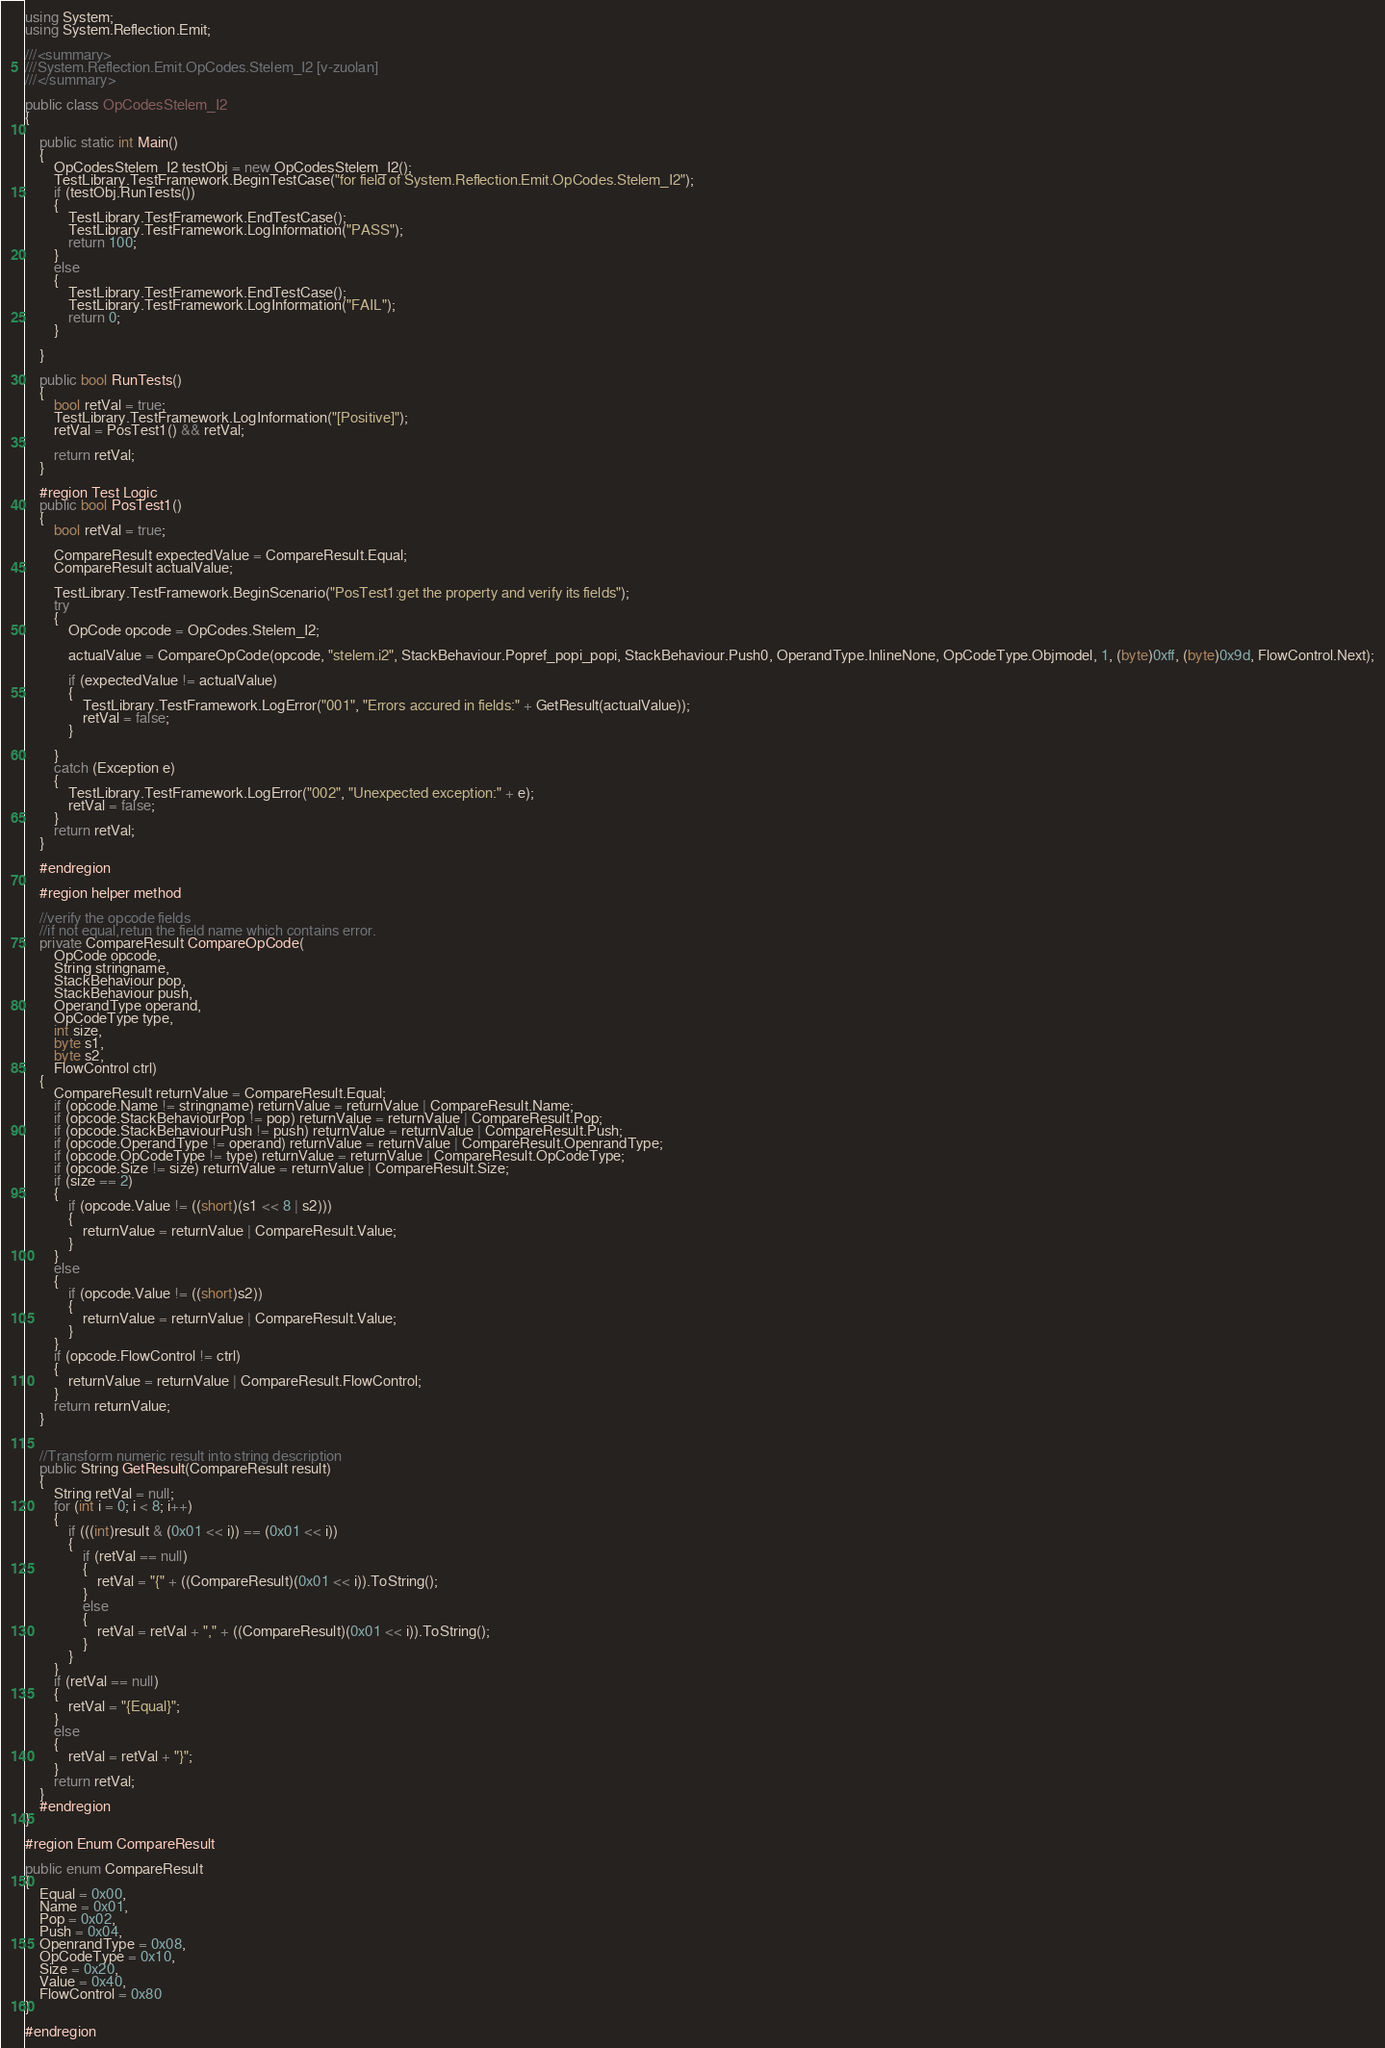Convert code to text. <code><loc_0><loc_0><loc_500><loc_500><_C#_>using System;
using System.Reflection.Emit;

///<summary>
///System.Reflection.Emit.OpCodes.Stelem_I2 [v-zuolan]
///</summary>

public class OpCodesStelem_I2
{

    public static int Main()
    {
        OpCodesStelem_I2 testObj = new OpCodesStelem_I2();
        TestLibrary.TestFramework.BeginTestCase("for field of System.Reflection.Emit.OpCodes.Stelem_I2");
        if (testObj.RunTests())
        {
            TestLibrary.TestFramework.EndTestCase();
            TestLibrary.TestFramework.LogInformation("PASS");
            return 100;
        }
        else
        {
            TestLibrary.TestFramework.EndTestCase();
            TestLibrary.TestFramework.LogInformation("FAIL");
            return 0;
        }

    }

    public bool RunTests()
    {
        bool retVal = true;
        TestLibrary.TestFramework.LogInformation("[Positive]");
        retVal = PosTest1() && retVal;

        return retVal;
    }

    #region Test Logic
    public bool PosTest1()
    {
        bool retVal = true;

        CompareResult expectedValue = CompareResult.Equal;
        CompareResult actualValue;

        TestLibrary.TestFramework.BeginScenario("PosTest1:get the property and verify its fields");
        try
        {
            OpCode opcode = OpCodes.Stelem_I2;

            actualValue = CompareOpCode(opcode, "stelem.i2", StackBehaviour.Popref_popi_popi, StackBehaviour.Push0, OperandType.InlineNone, OpCodeType.Objmodel, 1, (byte)0xff, (byte)0x9d, FlowControl.Next);

            if (expectedValue != actualValue)
            {
                TestLibrary.TestFramework.LogError("001", "Errors accured in fields:" + GetResult(actualValue));
                retVal = false;
            }

        }
        catch (Exception e)
        {
            TestLibrary.TestFramework.LogError("002", "Unexpected exception:" + e);
            retVal = false;
        }
        return retVal;
    }

    #endregion

    #region helper method

    //verify the opcode fields
    //if not equal,retun the field name which contains error. 
    private CompareResult CompareOpCode(
        OpCode opcode,
        String stringname,
        StackBehaviour pop,
        StackBehaviour push,
        OperandType operand,
        OpCodeType type,
        int size,
        byte s1,
        byte s2,
        FlowControl ctrl)
    {
        CompareResult returnValue = CompareResult.Equal;
        if (opcode.Name != stringname) returnValue = returnValue | CompareResult.Name;
        if (opcode.StackBehaviourPop != pop) returnValue = returnValue | CompareResult.Pop;
        if (opcode.StackBehaviourPush != push) returnValue = returnValue | CompareResult.Push;
        if (opcode.OperandType != operand) returnValue = returnValue | CompareResult.OpenrandType;
        if (opcode.OpCodeType != type) returnValue = returnValue | CompareResult.OpCodeType;
        if (opcode.Size != size) returnValue = returnValue | CompareResult.Size;
        if (size == 2)
        {
            if (opcode.Value != ((short)(s1 << 8 | s2)))
            {
                returnValue = returnValue | CompareResult.Value;
            }
        }
        else
        {
            if (opcode.Value != ((short)s2))
            {
                returnValue = returnValue | CompareResult.Value;
            }
        }
        if (opcode.FlowControl != ctrl)
        {
            returnValue = returnValue | CompareResult.FlowControl;
        }
        return returnValue;
    }


    //Transform numeric result into string description
    public String GetResult(CompareResult result)
    {
        String retVal = null;
        for (int i = 0; i < 8; i++)
        {
            if (((int)result & (0x01 << i)) == (0x01 << i))
            {
                if (retVal == null)
                {
                    retVal = "{" + ((CompareResult)(0x01 << i)).ToString();
                }
                else
                {
                    retVal = retVal + "," + ((CompareResult)(0x01 << i)).ToString();
                }
            }
        }
        if (retVal == null)
        {
            retVal = "{Equal}";
        }
        else
        {
            retVal = retVal + "}";
        }
        return retVal;
    }
    #endregion
}

#region Enum CompareResult

public enum CompareResult
{
    Equal = 0x00,
    Name = 0x01,
    Pop = 0x02,
    Push = 0x04,
    OpenrandType = 0x08,
    OpCodeType = 0x10,
    Size = 0x20,
    Value = 0x40,
    FlowControl = 0x80
}

#endregion</code> 